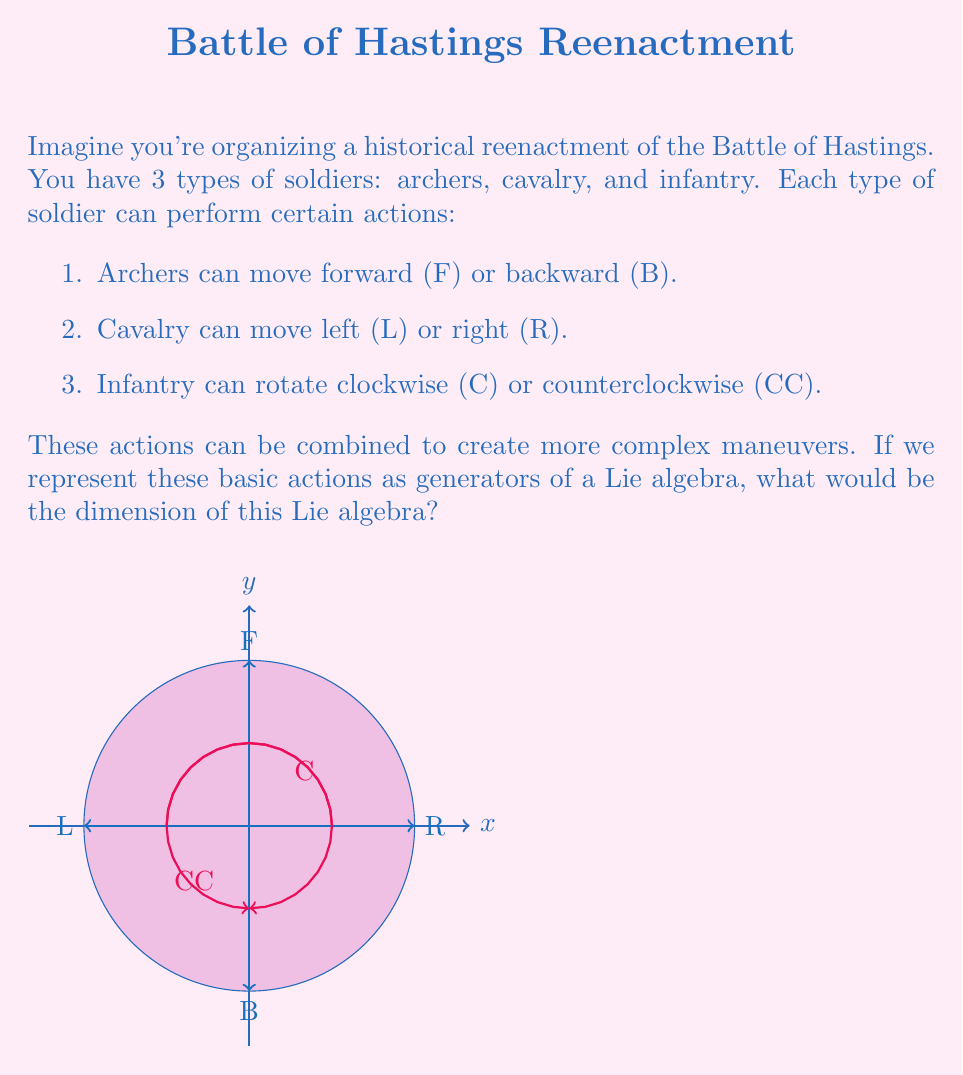Show me your answer to this math problem. Let's approach this step-by-step:

1) First, we need to identify the generators of our Lie algebra. From the question, we can see that there are 6 basic actions:
   $$ \{F, B, L, R, C, CC\} $$

2) In Lie algebra theory, the dimension of the algebra is equal to the number of linearly independent generators.

3) Now, we need to consider if all these generators are linearly independent:

   a) F and B are opposite actions along the same axis, so they can be considered as positive and negative movements along a single dimension. We can represent this as a single generator, let's call it X.
   
   b) Similarly, L and R are opposite actions along another axis, which we can represent as a single generator Y.
   
   c) C and CC are rotations in opposite directions, which can be represented as a single generator Z.

4) Therefore, our 6 basic actions can be reduced to 3 linearly independent generators:
   $$ \{X, Y, Z\} $$

5) In Lie algebra terms:
   $$ dim(L) = \text{number of linearly independent generators} $$

6) Here, we have 3 linearly independent generators, so the dimension of our Lie algebra is 3.
Answer: 3 